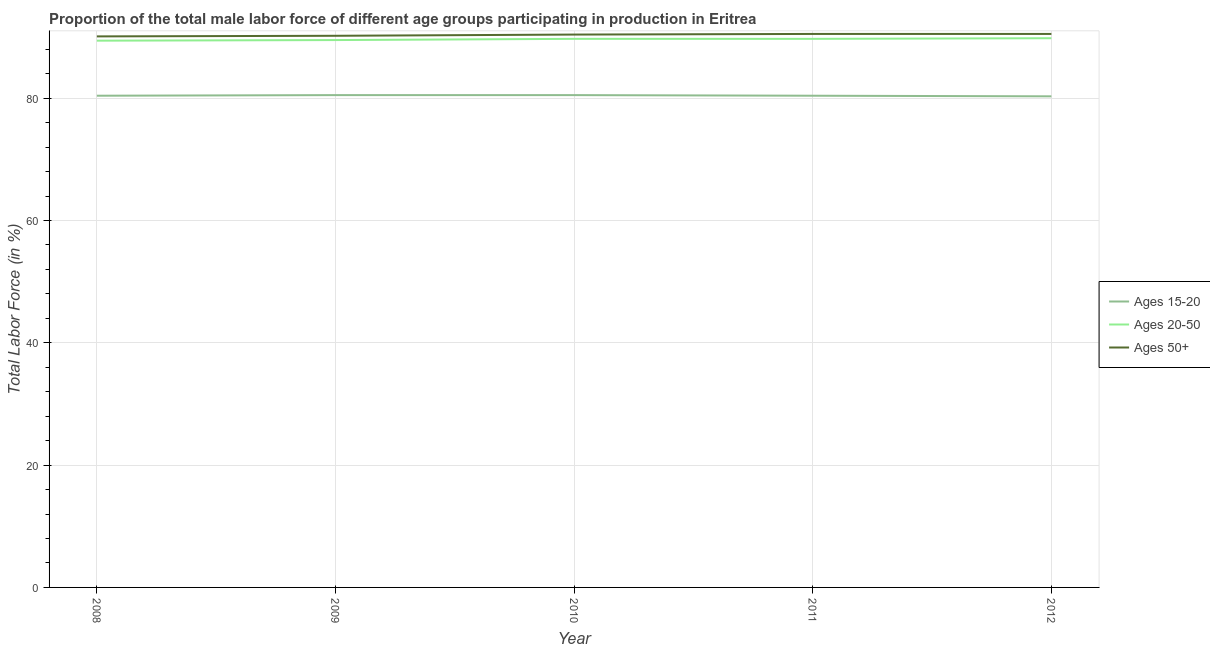Does the line corresponding to percentage of male labor force above age 50 intersect with the line corresponding to percentage of male labor force within the age group 15-20?
Your answer should be very brief. No. What is the percentage of male labor force above age 50 in 2010?
Your answer should be very brief. 90.4. Across all years, what is the maximum percentage of male labor force above age 50?
Offer a terse response. 90.5. Across all years, what is the minimum percentage of male labor force within the age group 15-20?
Ensure brevity in your answer.  80.3. In which year was the percentage of male labor force above age 50 maximum?
Give a very brief answer. 2011. What is the total percentage of male labor force within the age group 15-20 in the graph?
Your response must be concise. 402.1. What is the difference between the percentage of male labor force above age 50 in 2009 and that in 2010?
Make the answer very short. -0.2. What is the difference between the percentage of male labor force within the age group 20-50 in 2008 and the percentage of male labor force above age 50 in 2012?
Keep it short and to the point. -1.1. What is the average percentage of male labor force above age 50 per year?
Your answer should be very brief. 90.34. In the year 2011, what is the difference between the percentage of male labor force within the age group 15-20 and percentage of male labor force within the age group 20-50?
Provide a short and direct response. -9.3. In how many years, is the percentage of male labor force above age 50 greater than 76 %?
Offer a terse response. 5. Is the difference between the percentage of male labor force above age 50 in 2008 and 2009 greater than the difference between the percentage of male labor force within the age group 20-50 in 2008 and 2009?
Make the answer very short. No. What is the difference between the highest and the second highest percentage of male labor force within the age group 20-50?
Offer a very short reply. 0.1. What is the difference between the highest and the lowest percentage of male labor force above age 50?
Offer a very short reply. 0.4. Is the percentage of male labor force within the age group 20-50 strictly less than the percentage of male labor force above age 50 over the years?
Provide a short and direct response. Yes. How many lines are there?
Offer a very short reply. 3. How many years are there in the graph?
Offer a very short reply. 5. Does the graph contain grids?
Ensure brevity in your answer.  Yes. How many legend labels are there?
Your answer should be compact. 3. How are the legend labels stacked?
Provide a short and direct response. Vertical. What is the title of the graph?
Make the answer very short. Proportion of the total male labor force of different age groups participating in production in Eritrea. What is the Total Labor Force (in %) in Ages 15-20 in 2008?
Your response must be concise. 80.4. What is the Total Labor Force (in %) of Ages 20-50 in 2008?
Offer a terse response. 89.4. What is the Total Labor Force (in %) in Ages 50+ in 2008?
Make the answer very short. 90.1. What is the Total Labor Force (in %) in Ages 15-20 in 2009?
Offer a very short reply. 80.5. What is the Total Labor Force (in %) in Ages 20-50 in 2009?
Your answer should be compact. 89.5. What is the Total Labor Force (in %) in Ages 50+ in 2009?
Your answer should be compact. 90.2. What is the Total Labor Force (in %) of Ages 15-20 in 2010?
Offer a very short reply. 80.5. What is the Total Labor Force (in %) of Ages 20-50 in 2010?
Make the answer very short. 89.7. What is the Total Labor Force (in %) of Ages 50+ in 2010?
Make the answer very short. 90.4. What is the Total Labor Force (in %) of Ages 15-20 in 2011?
Your response must be concise. 80.4. What is the Total Labor Force (in %) in Ages 20-50 in 2011?
Your response must be concise. 89.7. What is the Total Labor Force (in %) in Ages 50+ in 2011?
Provide a short and direct response. 90.5. What is the Total Labor Force (in %) of Ages 15-20 in 2012?
Offer a very short reply. 80.3. What is the Total Labor Force (in %) of Ages 20-50 in 2012?
Provide a short and direct response. 89.8. What is the Total Labor Force (in %) of Ages 50+ in 2012?
Your answer should be compact. 90.5. Across all years, what is the maximum Total Labor Force (in %) in Ages 15-20?
Keep it short and to the point. 80.5. Across all years, what is the maximum Total Labor Force (in %) in Ages 20-50?
Ensure brevity in your answer.  89.8. Across all years, what is the maximum Total Labor Force (in %) in Ages 50+?
Make the answer very short. 90.5. Across all years, what is the minimum Total Labor Force (in %) of Ages 15-20?
Your answer should be compact. 80.3. Across all years, what is the minimum Total Labor Force (in %) of Ages 20-50?
Your answer should be compact. 89.4. Across all years, what is the minimum Total Labor Force (in %) of Ages 50+?
Give a very brief answer. 90.1. What is the total Total Labor Force (in %) in Ages 15-20 in the graph?
Offer a very short reply. 402.1. What is the total Total Labor Force (in %) in Ages 20-50 in the graph?
Provide a short and direct response. 448.1. What is the total Total Labor Force (in %) in Ages 50+ in the graph?
Keep it short and to the point. 451.7. What is the difference between the Total Labor Force (in %) of Ages 50+ in 2008 and that in 2009?
Ensure brevity in your answer.  -0.1. What is the difference between the Total Labor Force (in %) of Ages 15-20 in 2008 and that in 2010?
Ensure brevity in your answer.  -0.1. What is the difference between the Total Labor Force (in %) of Ages 20-50 in 2008 and that in 2010?
Offer a terse response. -0.3. What is the difference between the Total Labor Force (in %) of Ages 15-20 in 2008 and that in 2011?
Your answer should be compact. 0. What is the difference between the Total Labor Force (in %) in Ages 20-50 in 2008 and that in 2011?
Offer a very short reply. -0.3. What is the difference between the Total Labor Force (in %) in Ages 50+ in 2009 and that in 2010?
Keep it short and to the point. -0.2. What is the difference between the Total Labor Force (in %) of Ages 50+ in 2009 and that in 2011?
Offer a terse response. -0.3. What is the difference between the Total Labor Force (in %) of Ages 15-20 in 2009 and that in 2012?
Make the answer very short. 0.2. What is the difference between the Total Labor Force (in %) in Ages 50+ in 2009 and that in 2012?
Make the answer very short. -0.3. What is the difference between the Total Labor Force (in %) in Ages 20-50 in 2010 and that in 2011?
Make the answer very short. 0. What is the difference between the Total Labor Force (in %) in Ages 50+ in 2010 and that in 2011?
Your response must be concise. -0.1. What is the difference between the Total Labor Force (in %) of Ages 20-50 in 2010 and that in 2012?
Give a very brief answer. -0.1. What is the difference between the Total Labor Force (in %) in Ages 50+ in 2010 and that in 2012?
Provide a short and direct response. -0.1. What is the difference between the Total Labor Force (in %) in Ages 15-20 in 2011 and that in 2012?
Provide a short and direct response. 0.1. What is the difference between the Total Labor Force (in %) in Ages 15-20 in 2008 and the Total Labor Force (in %) in Ages 50+ in 2009?
Provide a short and direct response. -9.8. What is the difference between the Total Labor Force (in %) in Ages 20-50 in 2008 and the Total Labor Force (in %) in Ages 50+ in 2009?
Make the answer very short. -0.8. What is the difference between the Total Labor Force (in %) in Ages 15-20 in 2008 and the Total Labor Force (in %) in Ages 20-50 in 2010?
Provide a short and direct response. -9.3. What is the difference between the Total Labor Force (in %) of Ages 20-50 in 2008 and the Total Labor Force (in %) of Ages 50+ in 2010?
Give a very brief answer. -1. What is the difference between the Total Labor Force (in %) of Ages 15-20 in 2008 and the Total Labor Force (in %) of Ages 20-50 in 2011?
Ensure brevity in your answer.  -9.3. What is the difference between the Total Labor Force (in %) in Ages 15-20 in 2008 and the Total Labor Force (in %) in Ages 50+ in 2011?
Your answer should be very brief. -10.1. What is the difference between the Total Labor Force (in %) of Ages 20-50 in 2008 and the Total Labor Force (in %) of Ages 50+ in 2011?
Ensure brevity in your answer.  -1.1. What is the difference between the Total Labor Force (in %) in Ages 15-20 in 2008 and the Total Labor Force (in %) in Ages 50+ in 2012?
Give a very brief answer. -10.1. What is the difference between the Total Labor Force (in %) in Ages 15-20 in 2009 and the Total Labor Force (in %) in Ages 20-50 in 2010?
Keep it short and to the point. -9.2. What is the difference between the Total Labor Force (in %) of Ages 15-20 in 2009 and the Total Labor Force (in %) of Ages 50+ in 2010?
Your answer should be very brief. -9.9. What is the difference between the Total Labor Force (in %) in Ages 20-50 in 2009 and the Total Labor Force (in %) in Ages 50+ in 2010?
Make the answer very short. -0.9. What is the difference between the Total Labor Force (in %) of Ages 15-20 in 2009 and the Total Labor Force (in %) of Ages 20-50 in 2011?
Your response must be concise. -9.2. What is the difference between the Total Labor Force (in %) in Ages 20-50 in 2009 and the Total Labor Force (in %) in Ages 50+ in 2011?
Offer a terse response. -1. What is the difference between the Total Labor Force (in %) of Ages 20-50 in 2010 and the Total Labor Force (in %) of Ages 50+ in 2011?
Your answer should be compact. -0.8. What is the difference between the Total Labor Force (in %) of Ages 15-20 in 2010 and the Total Labor Force (in %) of Ages 20-50 in 2012?
Your answer should be compact. -9.3. What is the difference between the Total Labor Force (in %) in Ages 15-20 in 2011 and the Total Labor Force (in %) in Ages 50+ in 2012?
Provide a short and direct response. -10.1. What is the average Total Labor Force (in %) of Ages 15-20 per year?
Offer a very short reply. 80.42. What is the average Total Labor Force (in %) of Ages 20-50 per year?
Your answer should be very brief. 89.62. What is the average Total Labor Force (in %) of Ages 50+ per year?
Offer a terse response. 90.34. In the year 2008, what is the difference between the Total Labor Force (in %) in Ages 15-20 and Total Labor Force (in %) in Ages 50+?
Offer a terse response. -9.7. In the year 2008, what is the difference between the Total Labor Force (in %) in Ages 20-50 and Total Labor Force (in %) in Ages 50+?
Your response must be concise. -0.7. In the year 2009, what is the difference between the Total Labor Force (in %) of Ages 15-20 and Total Labor Force (in %) of Ages 20-50?
Provide a succinct answer. -9. In the year 2009, what is the difference between the Total Labor Force (in %) of Ages 20-50 and Total Labor Force (in %) of Ages 50+?
Make the answer very short. -0.7. In the year 2010, what is the difference between the Total Labor Force (in %) in Ages 15-20 and Total Labor Force (in %) in Ages 50+?
Make the answer very short. -9.9. In the year 2010, what is the difference between the Total Labor Force (in %) in Ages 20-50 and Total Labor Force (in %) in Ages 50+?
Provide a short and direct response. -0.7. In the year 2011, what is the difference between the Total Labor Force (in %) in Ages 20-50 and Total Labor Force (in %) in Ages 50+?
Provide a succinct answer. -0.8. What is the ratio of the Total Labor Force (in %) in Ages 15-20 in 2008 to that in 2009?
Offer a terse response. 1. What is the ratio of the Total Labor Force (in %) in Ages 15-20 in 2008 to that in 2010?
Provide a succinct answer. 1. What is the ratio of the Total Labor Force (in %) of Ages 50+ in 2008 to that in 2010?
Your response must be concise. 1. What is the ratio of the Total Labor Force (in %) of Ages 20-50 in 2008 to that in 2011?
Provide a succinct answer. 1. What is the ratio of the Total Labor Force (in %) of Ages 50+ in 2008 to that in 2011?
Give a very brief answer. 1. What is the ratio of the Total Labor Force (in %) of Ages 15-20 in 2009 to that in 2010?
Offer a very short reply. 1. What is the ratio of the Total Labor Force (in %) of Ages 15-20 in 2009 to that in 2011?
Provide a succinct answer. 1. What is the ratio of the Total Labor Force (in %) of Ages 50+ in 2009 to that in 2011?
Offer a terse response. 1. What is the ratio of the Total Labor Force (in %) of Ages 15-20 in 2009 to that in 2012?
Keep it short and to the point. 1. What is the ratio of the Total Labor Force (in %) in Ages 20-50 in 2010 to that in 2012?
Your response must be concise. 1. What is the ratio of the Total Labor Force (in %) of Ages 50+ in 2010 to that in 2012?
Ensure brevity in your answer.  1. What is the ratio of the Total Labor Force (in %) in Ages 20-50 in 2011 to that in 2012?
Provide a short and direct response. 1. What is the difference between the highest and the second highest Total Labor Force (in %) in Ages 15-20?
Your answer should be very brief. 0. What is the difference between the highest and the lowest Total Labor Force (in %) in Ages 15-20?
Offer a terse response. 0.2. 